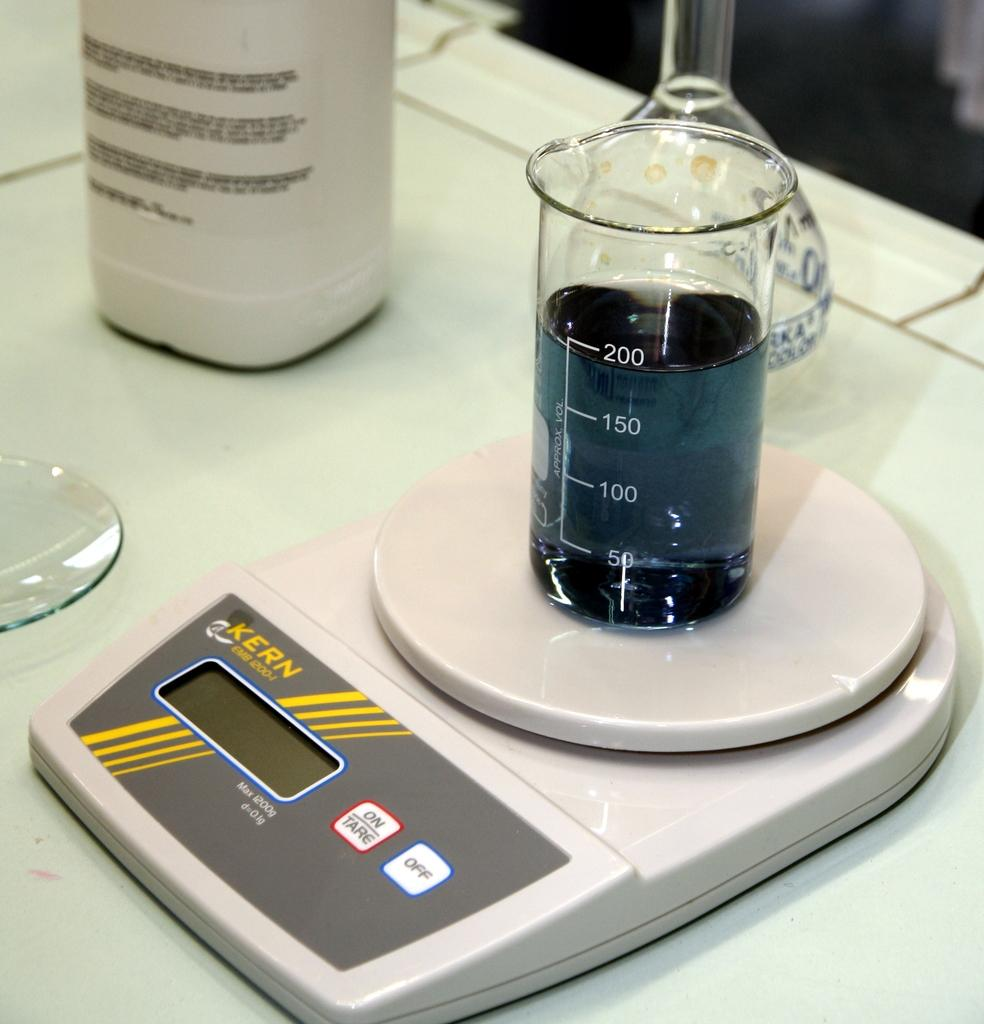<image>
Provide a brief description of the given image. A set of scales with a beaker on them; the scales are made by Kern. 